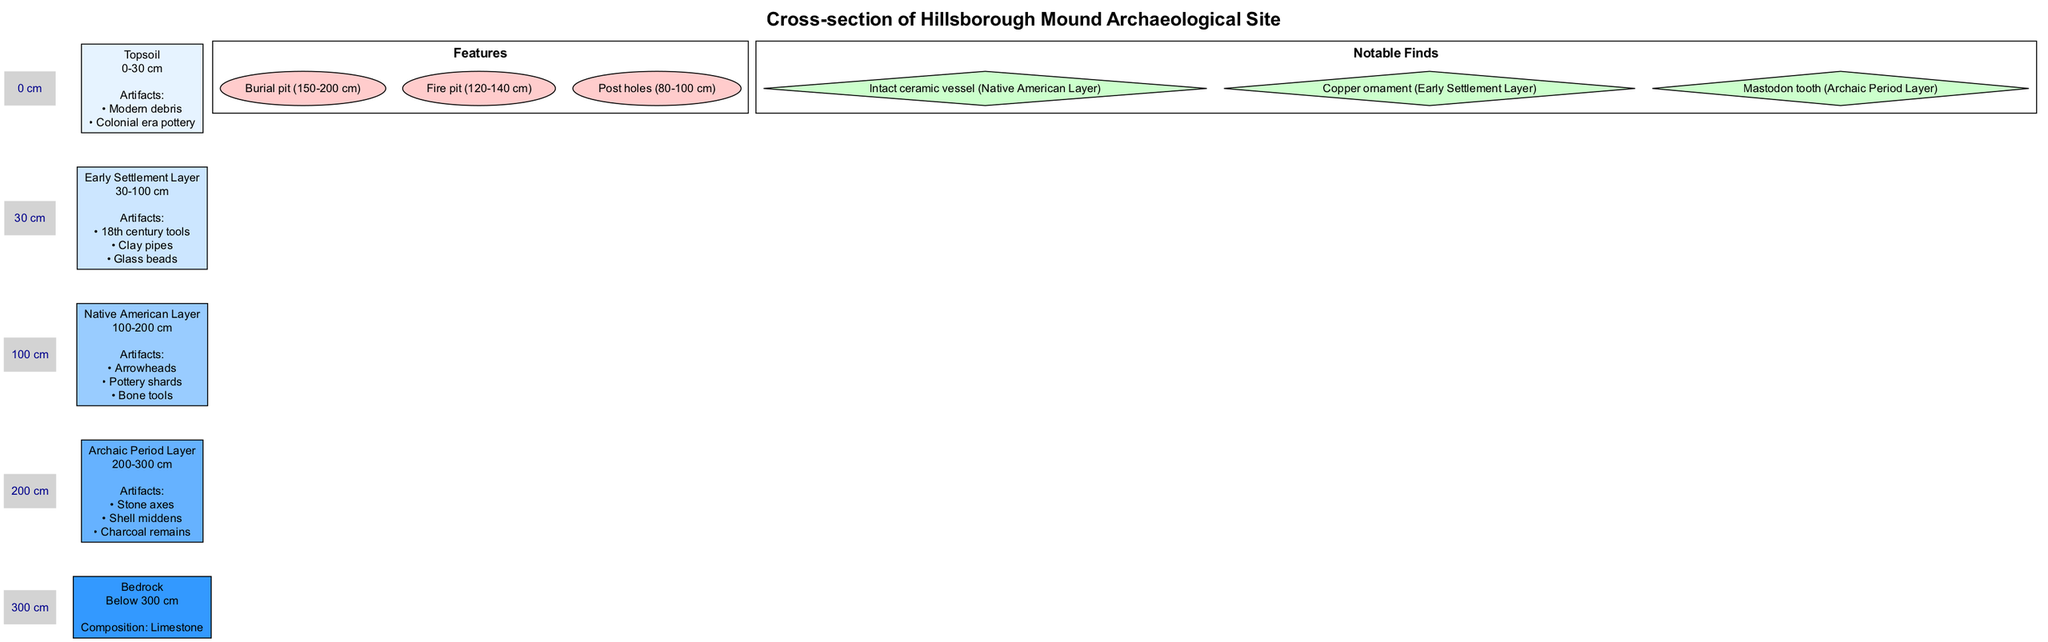What is the depth range of the Bedrock layer? The diagram specifies that the Bedrock layer is located below 300 cm, which indicates that it does not have an upper boundary in this diagram beyond that depth.
Answer: Below 300 cm How many artifacts are identified in the Early Settlement Layer? The Early Settlement Layer lists three specific artifacts: 18th century tools, clay pipes, and glass beads, giving a total count of three.
Answer: 3 What artifact is found in the Native American Layer? The diagram indicates that an intact ceramic vessel is one of the notable finds within the Native American Layer.
Answer: Intact ceramic vessel Which layer contains stone axes? By analyzing the artifacts listed under the Archaic Period Layer, it can be determined that stone axes are found there.
Answer: Archaic Period Layer What feature is located at 120-140 cm? The diagram specifies that a fire pit is positioned within the depth range of 120-140 cm, as marked in the features section of the diagram.
Answer: Fire pit Which layer is directly above the Native American Layer? The diagram shows that the Early Settlement Layer is positioned directly above the Native American Layer in the vertical cross-section.
Answer: Early Settlement Layer How many notable finds are listed in total? The diagram states three notable finds: an intact ceramic vessel, a copper ornament, and a mastodon tooth, thus totaling three finds.
Answer: 3 What is the composition of the Bedrock? The diagram provides that the composition of Bedrock is limestone, specifically noted in the information for that layer.
Answer: Limestone What artifacts are listed for the Topsoil layer? In the Topsoil layer, modern debris and Colonial era pottery are identified as the artifacts found, as stated in the layer's details.
Answer: Modern debris, Colonial era pottery 